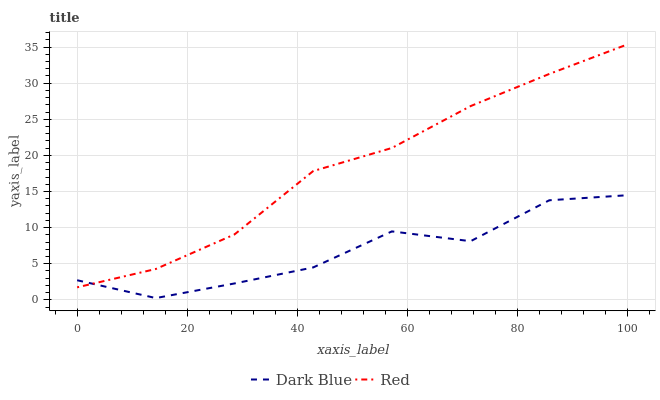Does Red have the minimum area under the curve?
Answer yes or no. No. Is Red the roughest?
Answer yes or no. No. Does Red have the lowest value?
Answer yes or no. No. 